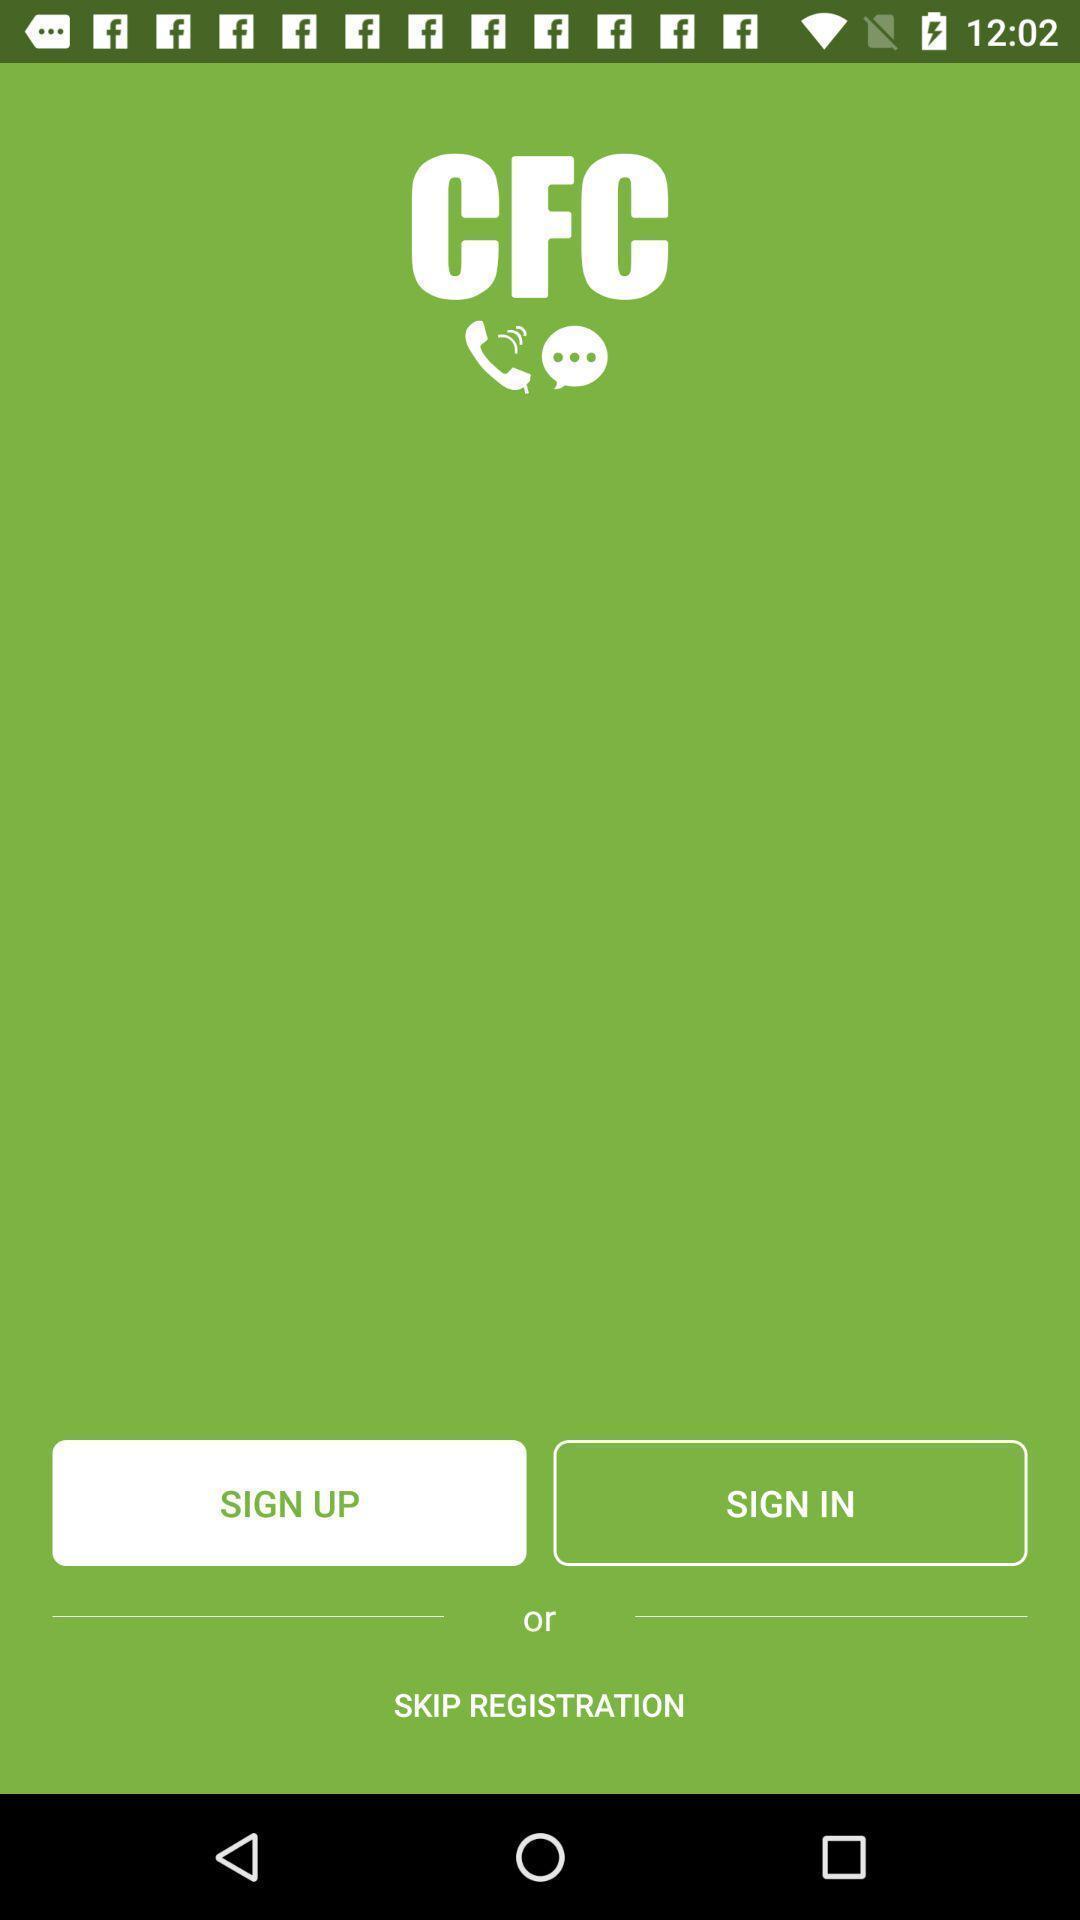Provide a description of this screenshot. Welcome page. 